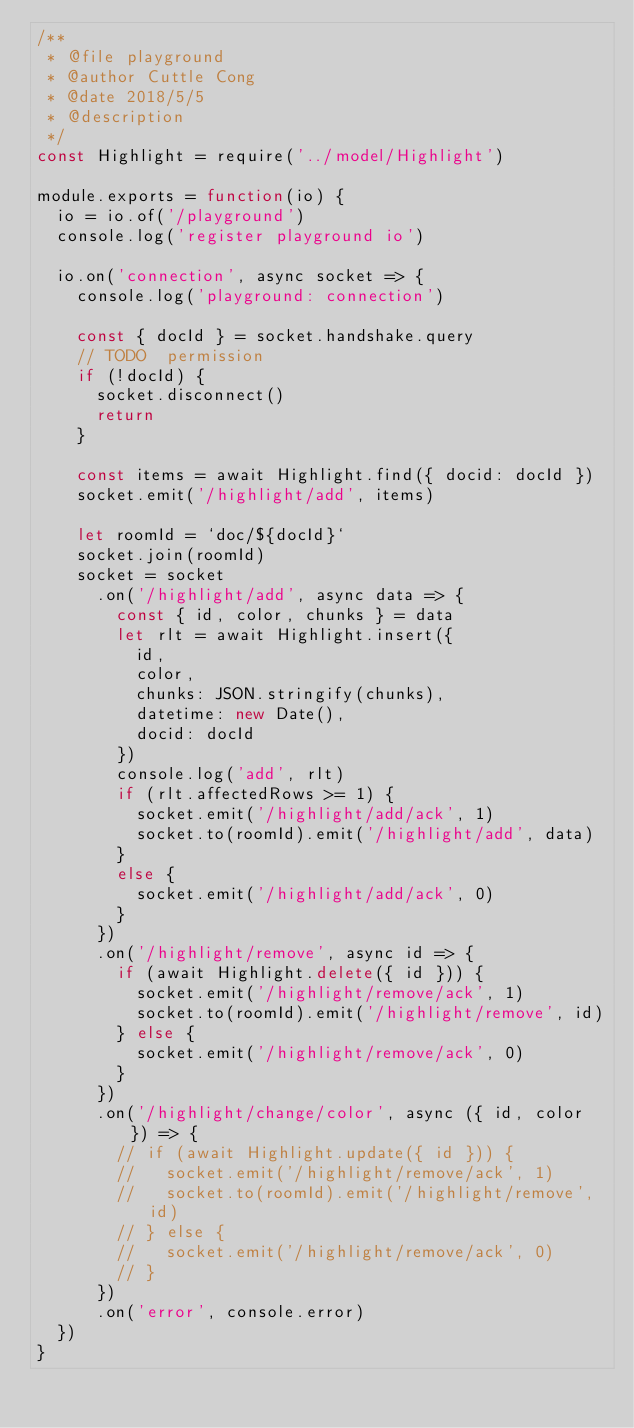Convert code to text. <code><loc_0><loc_0><loc_500><loc_500><_JavaScript_>/**
 * @file playground
 * @author Cuttle Cong
 * @date 2018/5/5
 * @description
 */
const Highlight = require('../model/Highlight')

module.exports = function(io) {
  io = io.of('/playground')
  console.log('register playground io')

  io.on('connection', async socket => {
    console.log('playground: connection')

    const { docId } = socket.handshake.query
    // TODO  permission
    if (!docId) {
      socket.disconnect()
      return
    }

    const items = await Highlight.find({ docid: docId })
    socket.emit('/highlight/add', items)

    let roomId = `doc/${docId}`
    socket.join(roomId)
    socket = socket
      .on('/highlight/add', async data => {
        const { id, color, chunks } = data
        let rlt = await Highlight.insert({
          id,
          color,
          chunks: JSON.stringify(chunks),
          datetime: new Date(),
          docid: docId
        })
        console.log('add', rlt)
        if (rlt.affectedRows >= 1) {
          socket.emit('/highlight/add/ack', 1)
          socket.to(roomId).emit('/highlight/add', data)
        }
        else {
          socket.emit('/highlight/add/ack', 0)
        }
      })
      .on('/highlight/remove', async id => {
        if (await Highlight.delete({ id })) {
          socket.emit('/highlight/remove/ack', 1)
          socket.to(roomId).emit('/highlight/remove', id)
        } else {
          socket.emit('/highlight/remove/ack', 0)
        }
      })
      .on('/highlight/change/color', async ({ id, color }) => {
        // if (await Highlight.update({ id })) {
        //   socket.emit('/highlight/remove/ack', 1)
        //   socket.to(roomId).emit('/highlight/remove', id)
        // } else {
        //   socket.emit('/highlight/remove/ack', 0)
        // }
      })
      .on('error', console.error)
  })
}
</code> 